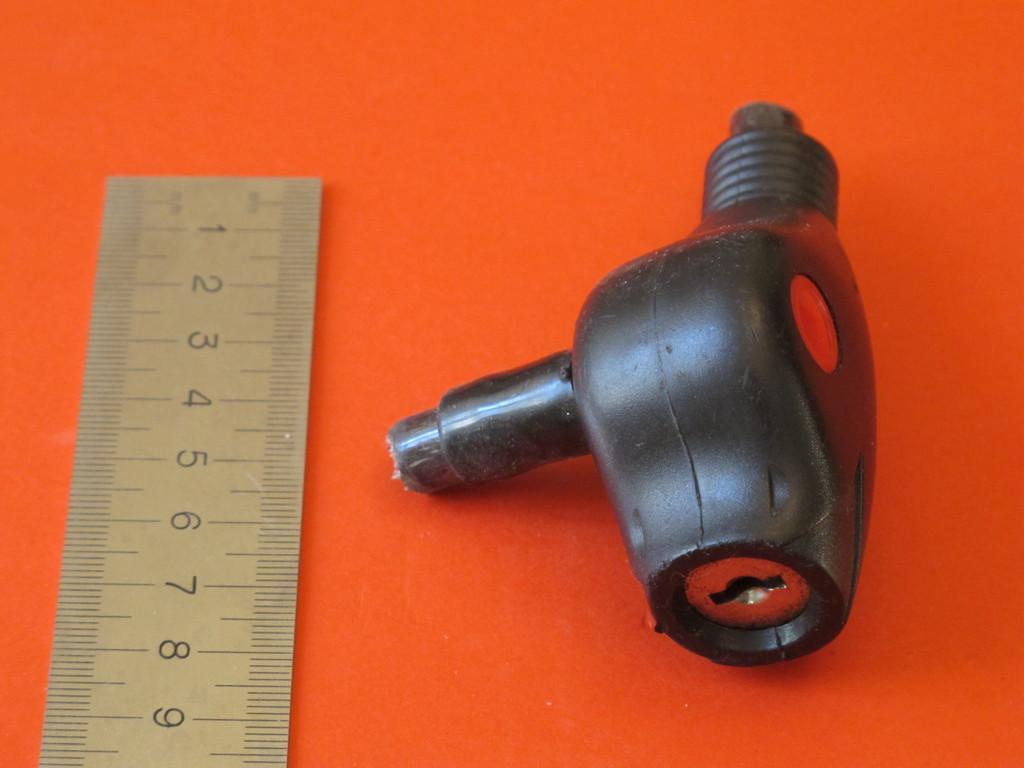What is the main object in the image? There is a scale in the image. Can you describe the other object in the image? Unfortunately, the provided facts only mention that there is another object in the image, but no specific details are given. How many eggs are visible in the image? There are no eggs present in the image. What type of clouds can be seen in the image? There is no mention of clouds in the provided facts, so we cannot determine if clouds are present in the image. 